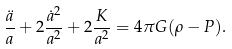Convert formula to latex. <formula><loc_0><loc_0><loc_500><loc_500>\frac { \ddot { a } } { a } + 2 \frac { \dot { a } ^ { 2 } } { a ^ { 2 } } + 2 \frac { K } { a ^ { 2 } } = 4 \pi G ( \rho - P ) .</formula> 